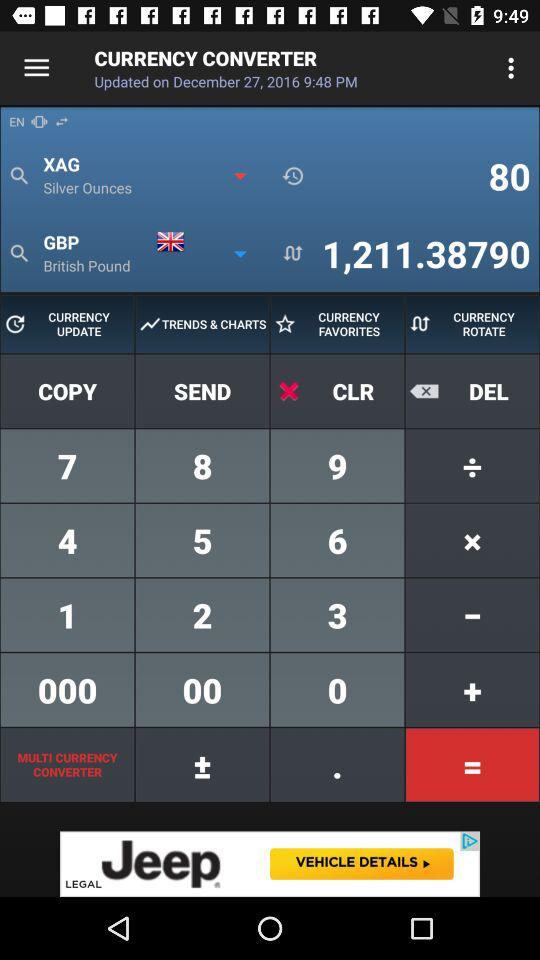What is the application name? The application name is "CURRENCY CONVERTER". 